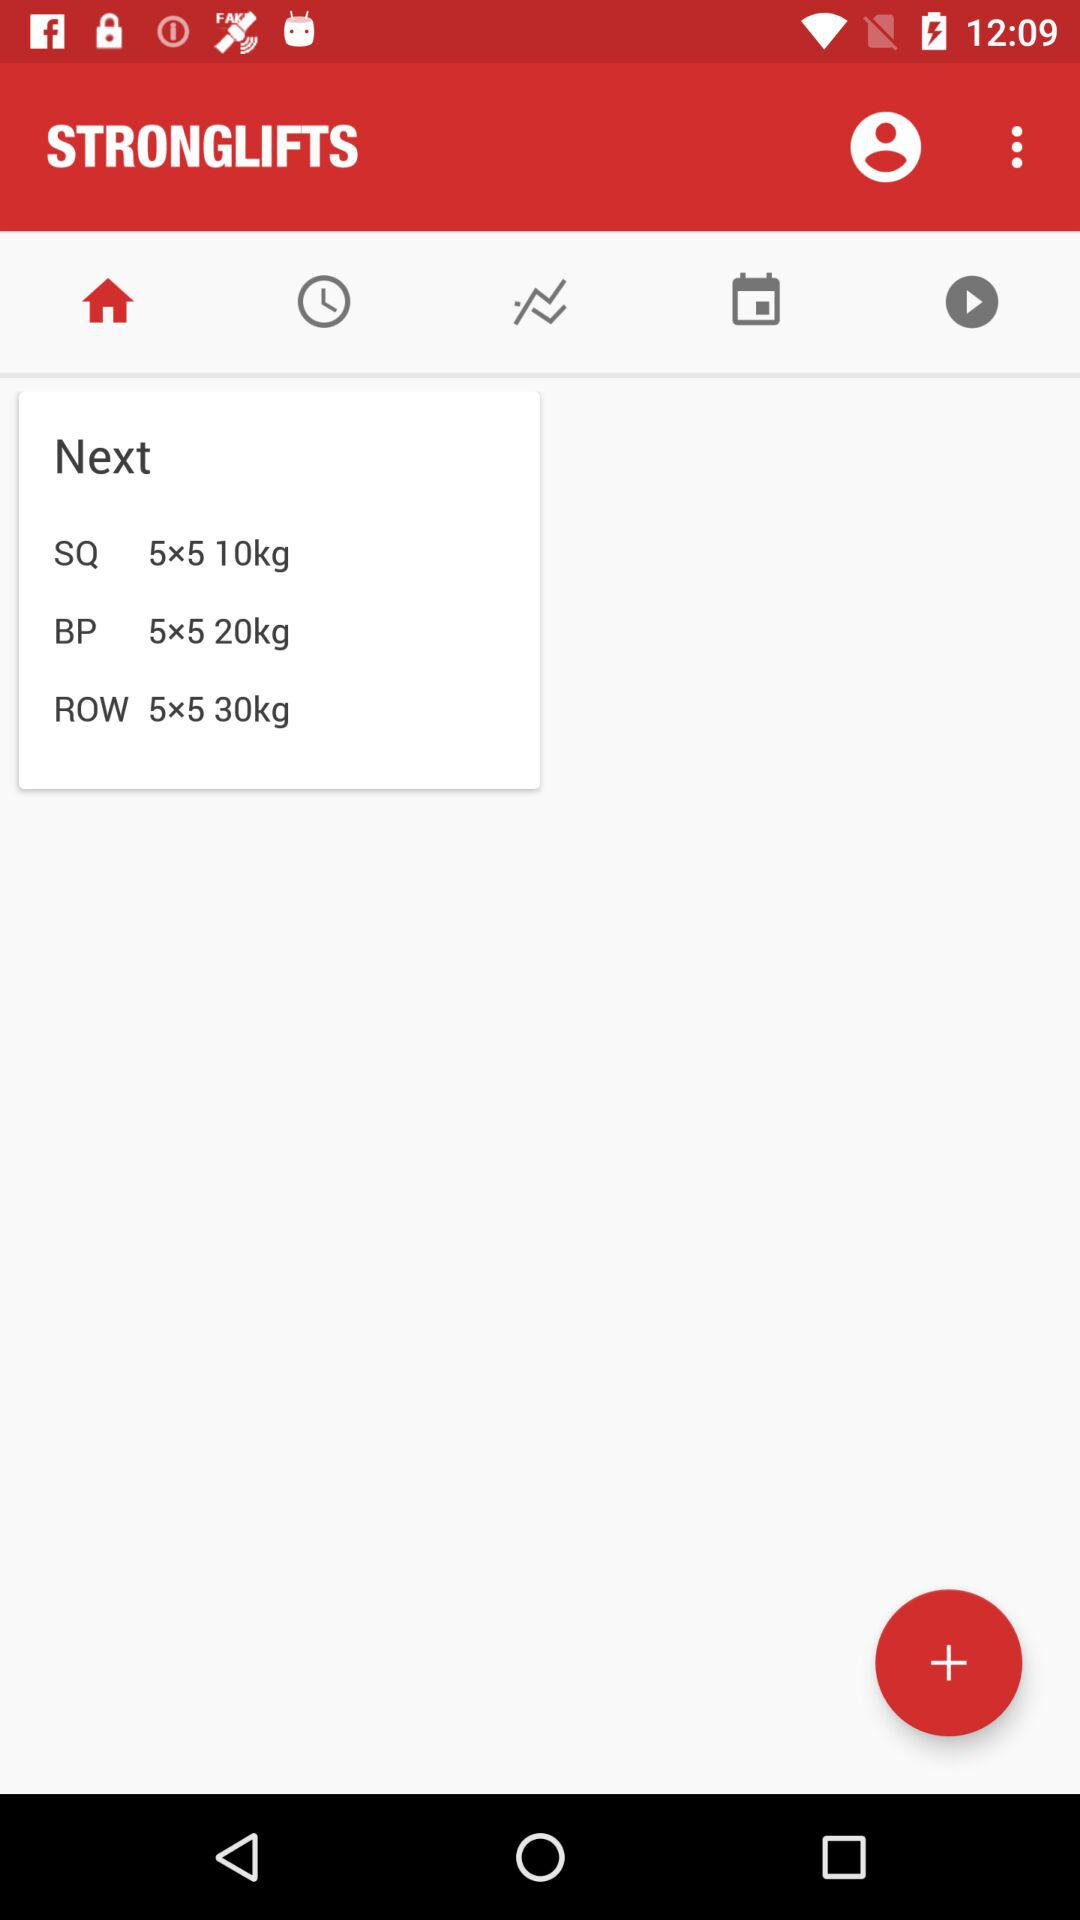What is the "SQ"? The "SQ" is "5×5 10kg". 